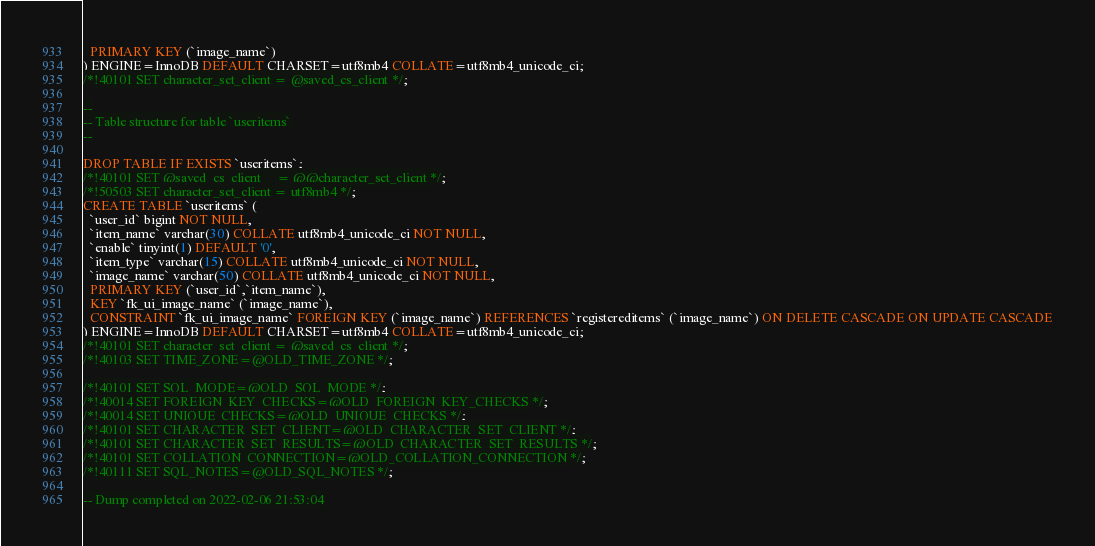<code> <loc_0><loc_0><loc_500><loc_500><_SQL_>  PRIMARY KEY (`image_name`)
) ENGINE=InnoDB DEFAULT CHARSET=utf8mb4 COLLATE=utf8mb4_unicode_ci;
/*!40101 SET character_set_client = @saved_cs_client */;

--
-- Table structure for table `useritems`
--

DROP TABLE IF EXISTS `useritems`;
/*!40101 SET @saved_cs_client     = @@character_set_client */;
/*!50503 SET character_set_client = utf8mb4 */;
CREATE TABLE `useritems` (
  `user_id` bigint NOT NULL,
  `item_name` varchar(30) COLLATE utf8mb4_unicode_ci NOT NULL,
  `enable` tinyint(1) DEFAULT '0',
  `item_type` varchar(15) COLLATE utf8mb4_unicode_ci NOT NULL,
  `image_name` varchar(50) COLLATE utf8mb4_unicode_ci NOT NULL,
  PRIMARY KEY (`user_id`,`item_name`),
  KEY `fk_ui_image_name` (`image_name`),
  CONSTRAINT `fk_ui_image_name` FOREIGN KEY (`image_name`) REFERENCES `registereditems` (`image_name`) ON DELETE CASCADE ON UPDATE CASCADE
) ENGINE=InnoDB DEFAULT CHARSET=utf8mb4 COLLATE=utf8mb4_unicode_ci;
/*!40101 SET character_set_client = @saved_cs_client */;
/*!40103 SET TIME_ZONE=@OLD_TIME_ZONE */;

/*!40101 SET SQL_MODE=@OLD_SQL_MODE */;
/*!40014 SET FOREIGN_KEY_CHECKS=@OLD_FOREIGN_KEY_CHECKS */;
/*!40014 SET UNIQUE_CHECKS=@OLD_UNIQUE_CHECKS */;
/*!40101 SET CHARACTER_SET_CLIENT=@OLD_CHARACTER_SET_CLIENT */;
/*!40101 SET CHARACTER_SET_RESULTS=@OLD_CHARACTER_SET_RESULTS */;
/*!40101 SET COLLATION_CONNECTION=@OLD_COLLATION_CONNECTION */;
/*!40111 SET SQL_NOTES=@OLD_SQL_NOTES */;

-- Dump completed on 2022-02-06 21:53:04
</code> 